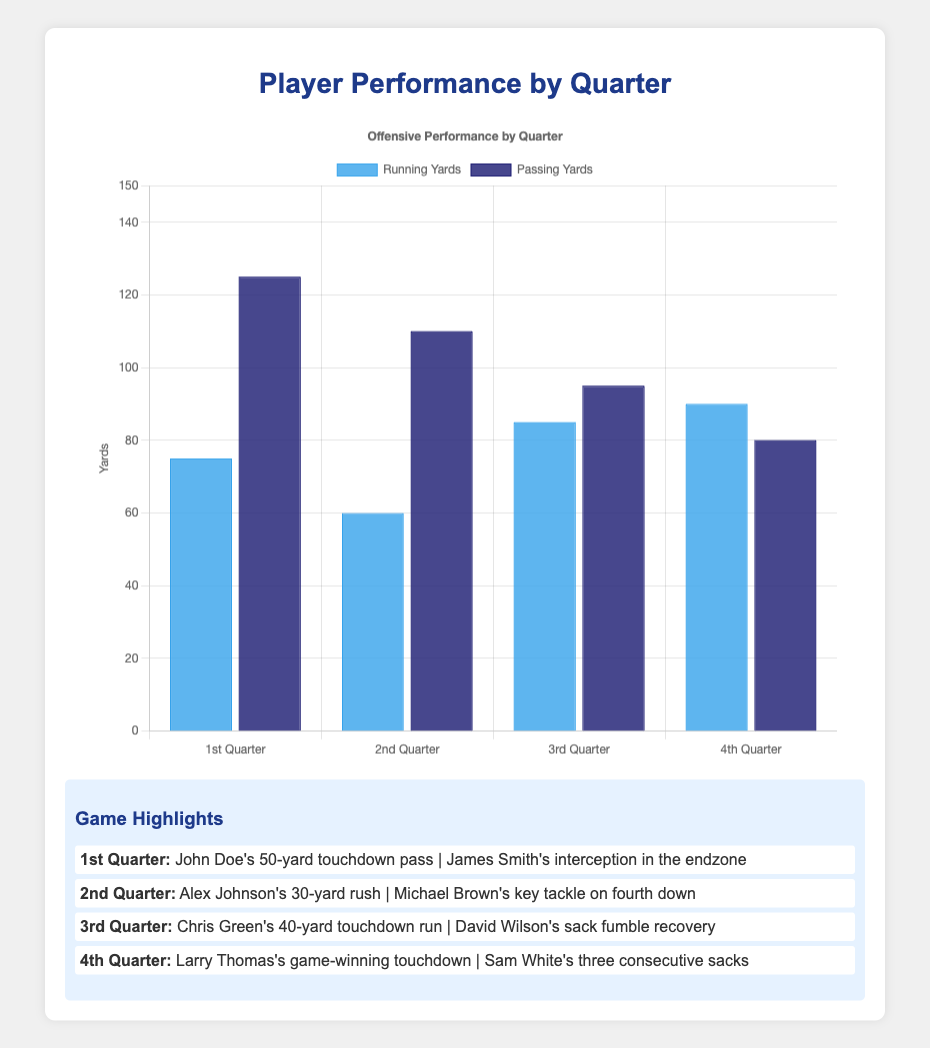How many total running yards were achieved by both teams in all quarters combined? Add up all the running yards from each quarter: 75 (1st Q) + 60 (2nd Q) + 85 (3rd Q) + 90 (4th Q) = 310 yards
Answer: 310 Which quarter had the highest passing yards? Compare the passing yards from each quarter: 125 (1st Q), 110 (2nd Q), 95 (3rd Q), 80 (4th Q). The 1st Quarter has the highest passing yards.
Answer: 1st Quarter What are the colors of the bars representing running yards and passing yards on the chart? The bars are color-coded: running yards are in blue, and passing yards are in dark blue.
Answer: Blue and dark blue How many total touchdowns were scored by the University of Texas in the first two quarters? Add the touchdowns from the 1st Quarter (2) and the 2nd Quarter (1): 2 + 1 = 3 touchdowns
Answer: 3 Which quarter had the most total tackles? Compare the number of tackles from each quarter: 8 (1st Q), 10 (2nd Q), 12 (3rd Q), 11 (4th Q). The 3rd Quarter had the most tackles.
Answer: 3rd Quarter How did the passing yards in the 2nd Quarter compare to the passing yards in the 4th Quarter? Compare the passing yards: 110 yards (2nd Q) and 80 yards (4th Q). 110 is greater than 80.
Answer: Greater in the 2nd Quarter What is the average number of running yards per quarter for the University of Oklahoma? Only consider the 3rd and 4th quarters (University of Oklahoma): (85 + 90) / 2 = 87.5 yards
Answer: 87.5 yards Which team's players made three consecutive sacks in the fourth quarter? Referring to the highlights, Sam White made three consecutive sacks for the University of Oklahoma in the 4th Quarter.
Answer: University of Oklahoma How many passing yards were achieved in the 1st and 3rd Quarters combined? Add the passing yards from 1st and 3rd Quarters: 125 (1st Q) + 95 (3rd Q) = 220 yards
Answer: 220 What can you infer from the offensive highlights of the 1st Quarter? The highlight mentions John Doe's 50-yard touchdown pass, indicating a significant offensive play resulting in a touchdown.
Answer: Significant offensive play resulting in a touchdown 